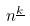<formula> <loc_0><loc_0><loc_500><loc_500>n ^ { \underline { k } }</formula> 